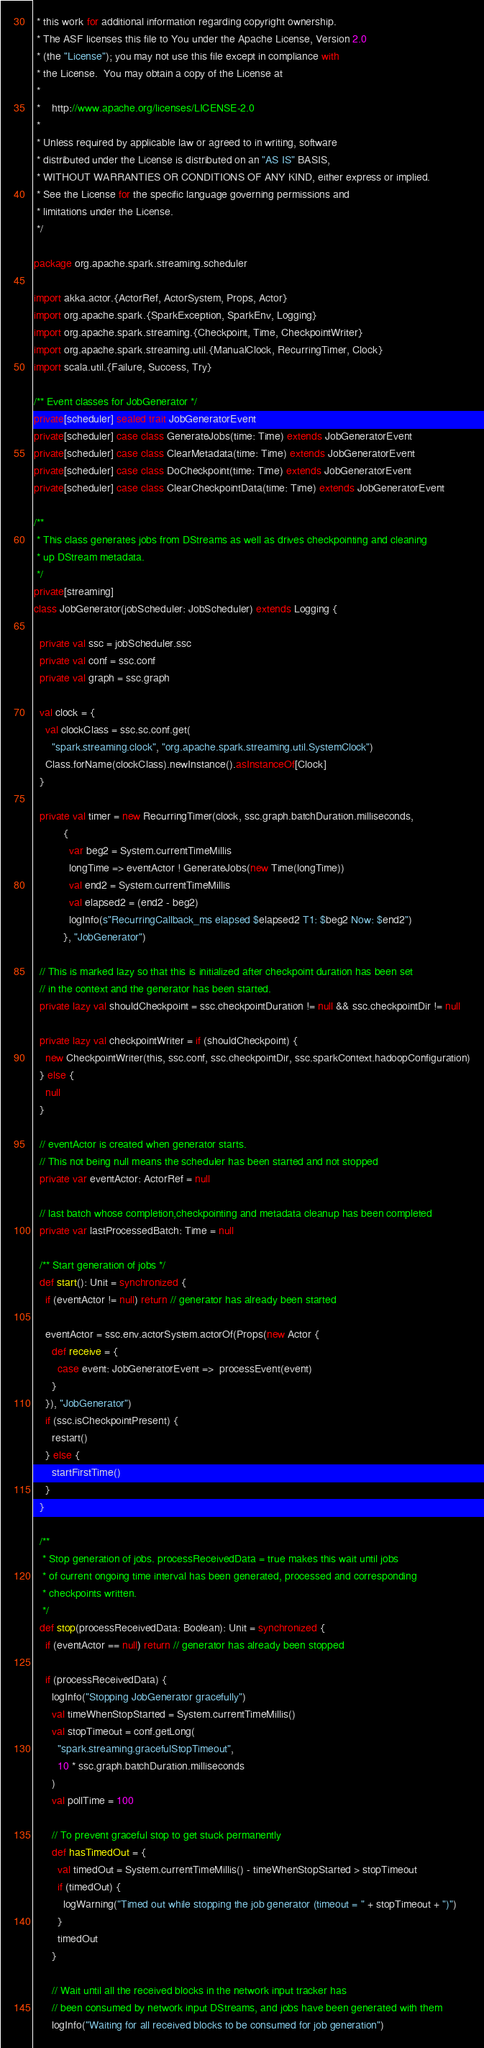<code> <loc_0><loc_0><loc_500><loc_500><_Scala_> * this work for additional information regarding copyright ownership.
 * The ASF licenses this file to You under the Apache License, Version 2.0
 * (the "License"); you may not use this file except in compliance with
 * the License.  You may obtain a copy of the License at
 *
 *    http://www.apache.org/licenses/LICENSE-2.0
 *
 * Unless required by applicable law or agreed to in writing, software
 * distributed under the License is distributed on an "AS IS" BASIS,
 * WITHOUT WARRANTIES OR CONDITIONS OF ANY KIND, either express or implied.
 * See the License for the specific language governing permissions and
 * limitations under the License.
 */

package org.apache.spark.streaming.scheduler

import akka.actor.{ActorRef, ActorSystem, Props, Actor}
import org.apache.spark.{SparkException, SparkEnv, Logging}
import org.apache.spark.streaming.{Checkpoint, Time, CheckpointWriter}
import org.apache.spark.streaming.util.{ManualClock, RecurringTimer, Clock}
import scala.util.{Failure, Success, Try}

/** Event classes for JobGenerator */
private[scheduler] sealed trait JobGeneratorEvent
private[scheduler] case class GenerateJobs(time: Time) extends JobGeneratorEvent
private[scheduler] case class ClearMetadata(time: Time) extends JobGeneratorEvent
private[scheduler] case class DoCheckpoint(time: Time) extends JobGeneratorEvent
private[scheduler] case class ClearCheckpointData(time: Time) extends JobGeneratorEvent

/**
 * This class generates jobs from DStreams as well as drives checkpointing and cleaning
 * up DStream metadata.
 */
private[streaming]
class JobGenerator(jobScheduler: JobScheduler) extends Logging {

  private val ssc = jobScheduler.ssc
  private val conf = ssc.conf
  private val graph = ssc.graph

  val clock = {
    val clockClass = ssc.sc.conf.get(
      "spark.streaming.clock", "org.apache.spark.streaming.util.SystemClock")
    Class.forName(clockClass).newInstance().asInstanceOf[Clock]
  }

  private val timer = new RecurringTimer(clock, ssc.graph.batchDuration.milliseconds,
          {
            var beg2 = System.currentTimeMillis
            longTime => eventActor ! GenerateJobs(new Time(longTime))
            val end2 = System.currentTimeMillis
            val elapsed2 = (end2 - beg2)
            logInfo(s"RecurringCallback_ms elapsed $elapsed2 T1: $beg2 Now: $end2")
          }, "JobGenerator")

  // This is marked lazy so that this is initialized after checkpoint duration has been set
  // in the context and the generator has been started.
  private lazy val shouldCheckpoint = ssc.checkpointDuration != null && ssc.checkpointDir != null

  private lazy val checkpointWriter = if (shouldCheckpoint) {
    new CheckpointWriter(this, ssc.conf, ssc.checkpointDir, ssc.sparkContext.hadoopConfiguration)
  } else {
    null
  }

  // eventActor is created when generator starts.
  // This not being null means the scheduler has been started and not stopped
  private var eventActor: ActorRef = null

  // last batch whose completion,checkpointing and metadata cleanup has been completed
  private var lastProcessedBatch: Time = null

  /** Start generation of jobs */
  def start(): Unit = synchronized {
    if (eventActor != null) return // generator has already been started

    eventActor = ssc.env.actorSystem.actorOf(Props(new Actor {
      def receive = {
        case event: JobGeneratorEvent =>  processEvent(event)
      }
    }), "JobGenerator")
    if (ssc.isCheckpointPresent) {
      restart()
    } else {
      startFirstTime()
    }
  }

  /**
   * Stop generation of jobs. processReceivedData = true makes this wait until jobs
   * of current ongoing time interval has been generated, processed and corresponding
   * checkpoints written.
   */
  def stop(processReceivedData: Boolean): Unit = synchronized {
    if (eventActor == null) return // generator has already been stopped

    if (processReceivedData) {
      logInfo("Stopping JobGenerator gracefully")
      val timeWhenStopStarted = System.currentTimeMillis()
      val stopTimeout = conf.getLong(
        "spark.streaming.gracefulStopTimeout",
        10 * ssc.graph.batchDuration.milliseconds
      )
      val pollTime = 100

      // To prevent graceful stop to get stuck permanently
      def hasTimedOut = {
        val timedOut = System.currentTimeMillis() - timeWhenStopStarted > stopTimeout
        if (timedOut) {
          logWarning("Timed out while stopping the job generator (timeout = " + stopTimeout + ")")
        }
        timedOut
      }

      // Wait until all the received blocks in the network input tracker has
      // been consumed by network input DStreams, and jobs have been generated with them
      logInfo("Waiting for all received blocks to be consumed for job generation")</code> 